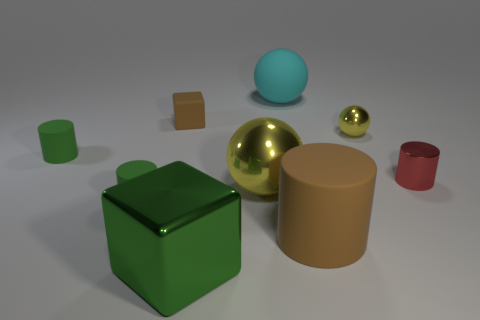Add 1 tiny gray rubber balls. How many objects exist? 10 Subtract all spheres. How many objects are left? 6 Subtract all small cylinders. Subtract all cyan matte things. How many objects are left? 5 Add 7 large brown cylinders. How many large brown cylinders are left? 8 Add 6 small cyan metallic blocks. How many small cyan metallic blocks exist? 6 Subtract 1 brown cubes. How many objects are left? 8 